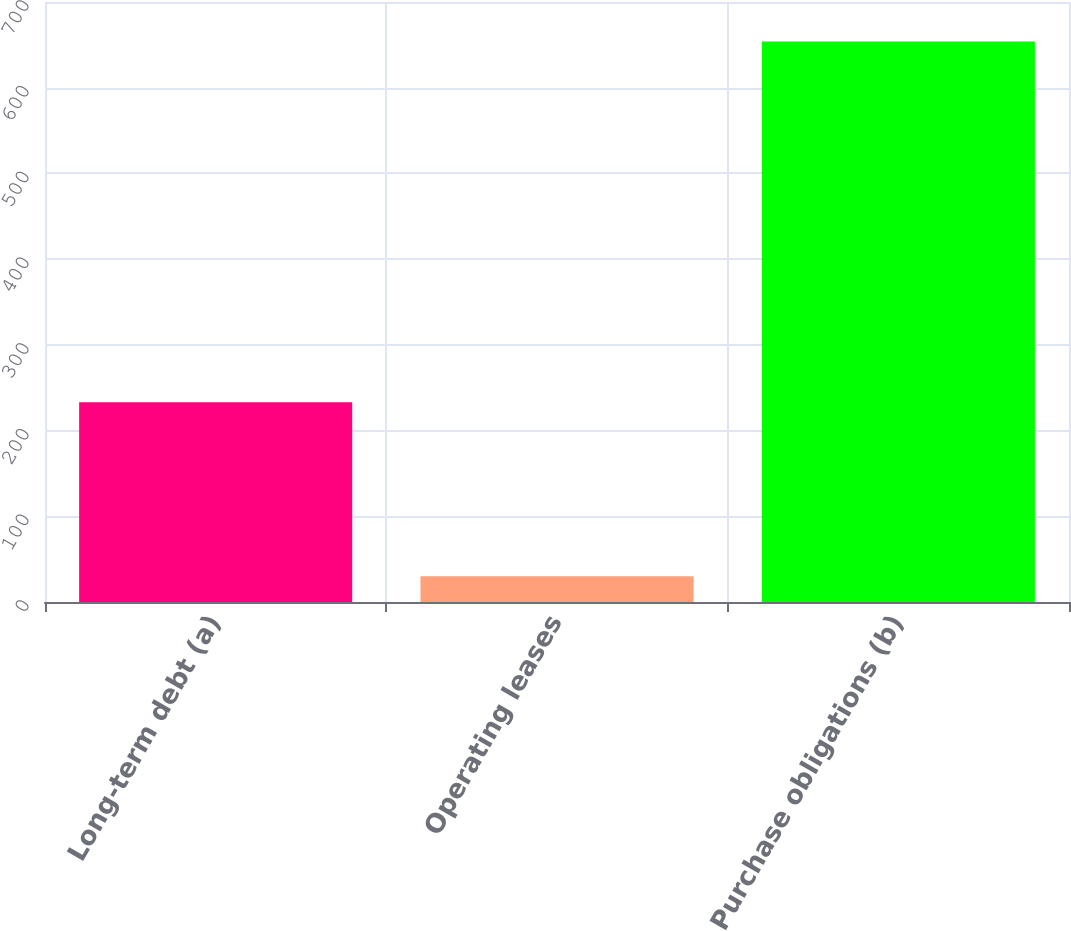<chart> <loc_0><loc_0><loc_500><loc_500><bar_chart><fcel>Long-term debt (a)<fcel>Operating leases<fcel>Purchase obligations (b)<nl><fcel>233<fcel>30<fcel>654<nl></chart> 